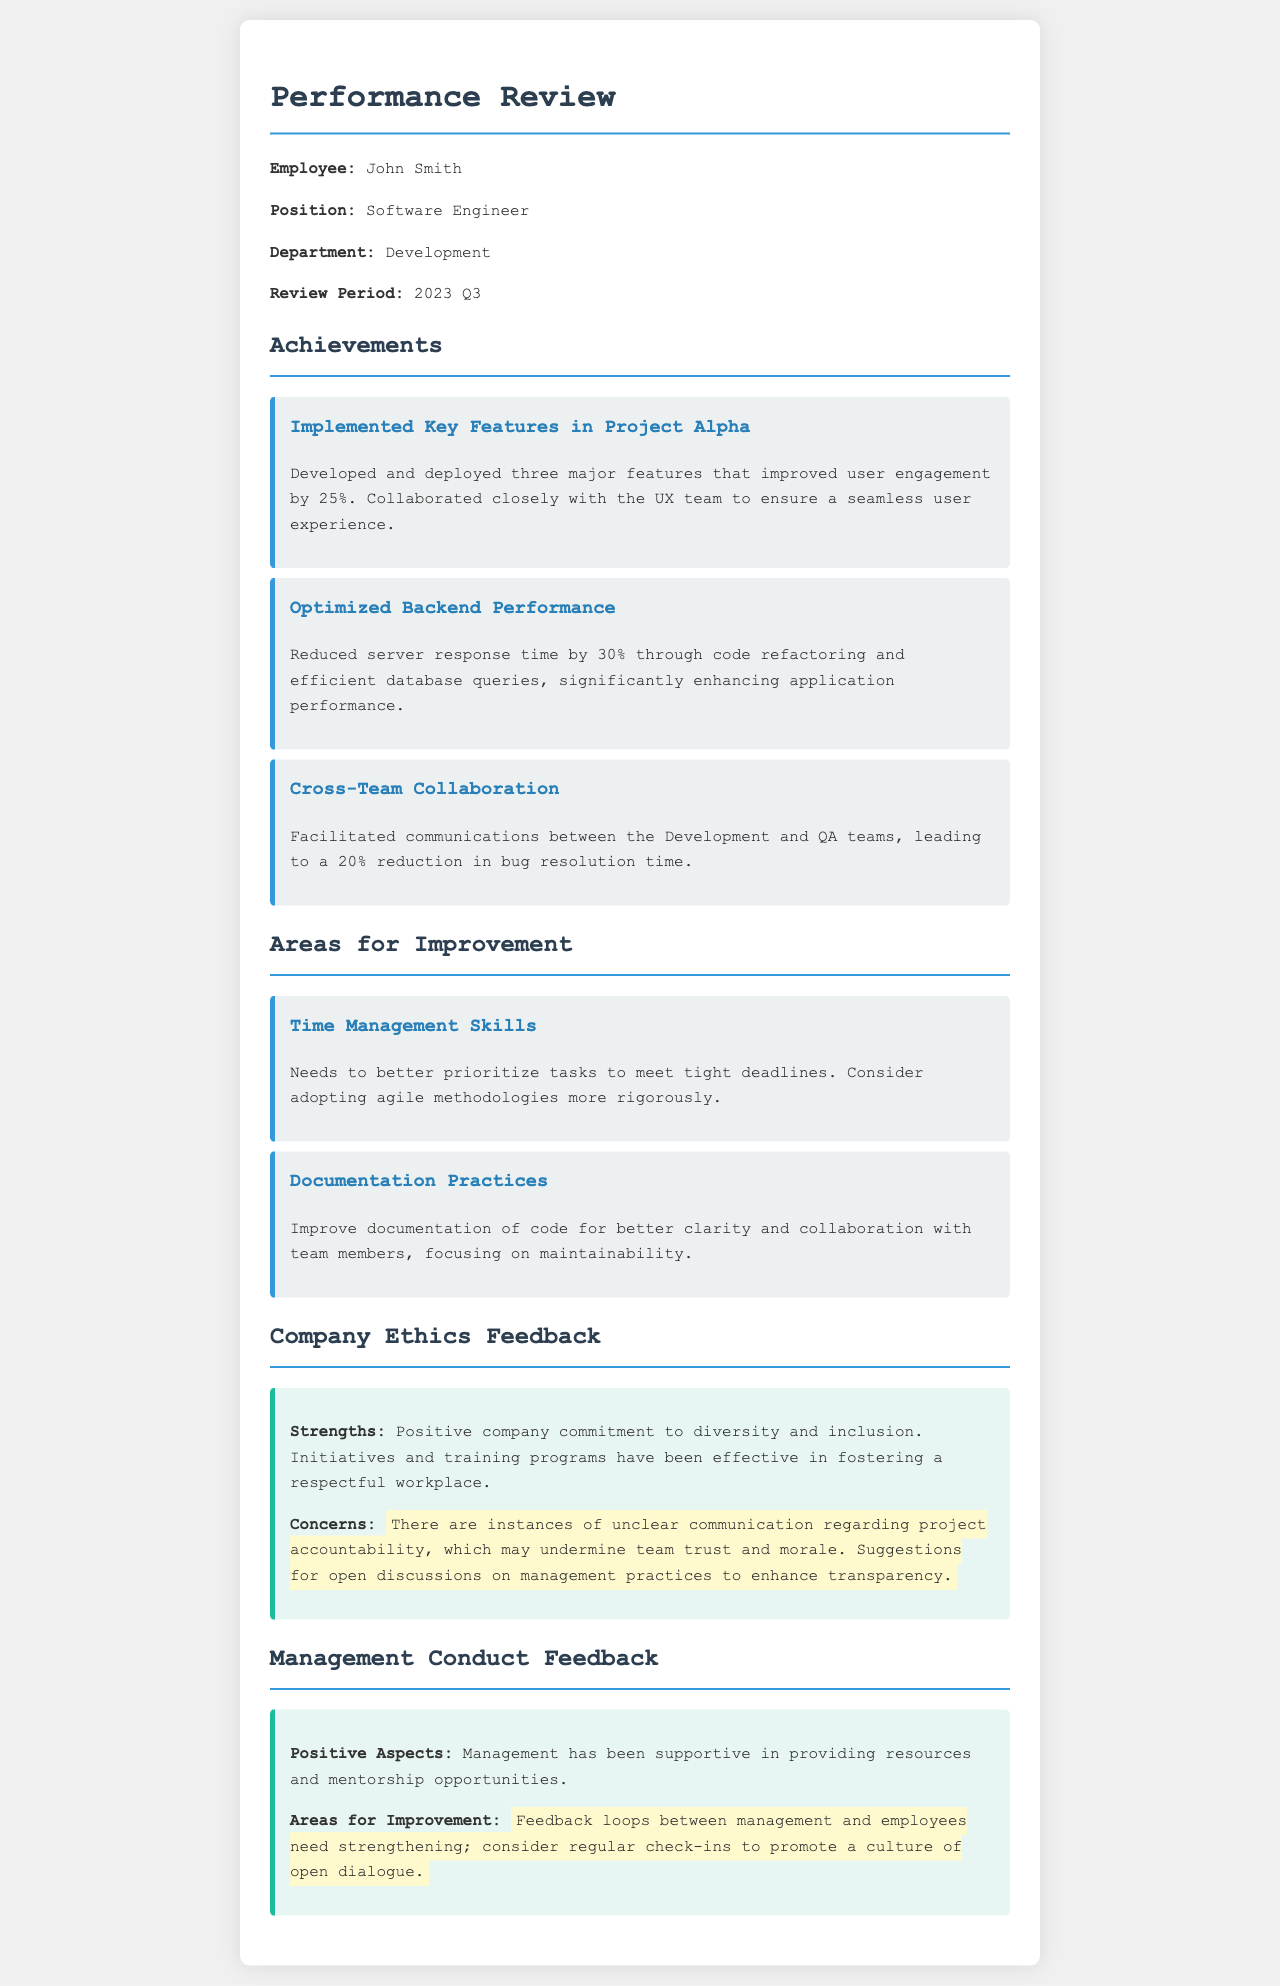What is the employee's name? The employee's name is stated at the beginning of the document under the employee section.
Answer: John Smith What position does the employee hold? The position is mentioned in the employee section of the document.
Answer: Software Engineer How many major features were implemented in Project Alpha? This number can be found in the achievements section related to Project Alpha.
Answer: Three By what percentage was the server response time reduced? The percentage reduction in server response time is detailed in the achievements section.
Answer: 30% What is one area for improvement mentioned? The areas for improvement are listed in the respective section of the document.
Answer: Time Management Skills What positive aspect is noted about management support? This information is provided in the management conduct feedback section.
Answer: Resources and mentorship opportunities What has been identified as a concern in company ethics? This concern is highlighted in the company ethics feedback section about communication.
Answer: Project accountability What percentage reduction in bug resolution time resulted from cross-team collaboration? The document states the percentage reduction and can be found in the achievements section.
Answer: 20% What training has been effective according to the company ethics feedback? The type of training mentioned is found in the strengths part of the feedback section.
Answer: Diversity and inclusion 